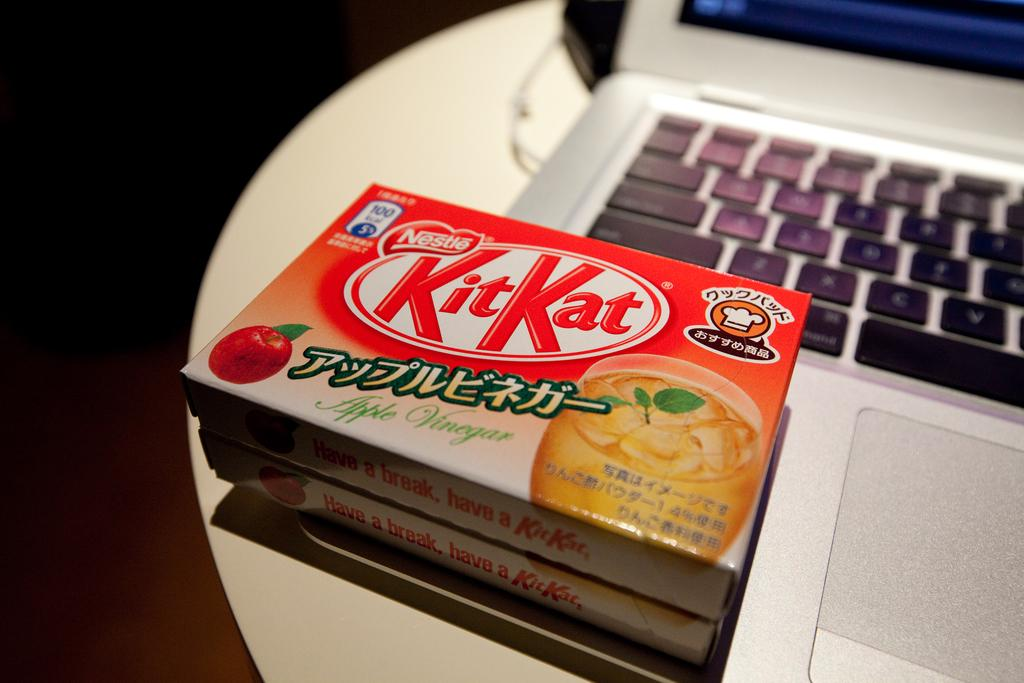What is the main piece of furniture in the image? There is a table in the image. What is placed on the table? There is a laptop on the table. What is visible on the laptop screen? There are boxes on the laptop screen. What type of doll is sitting next to the laptop? There is no doll present in the image. What fact can be learned about the growth of the laptop's battery life from the image? The image does not provide any information about the laptop's battery life or its growth. 